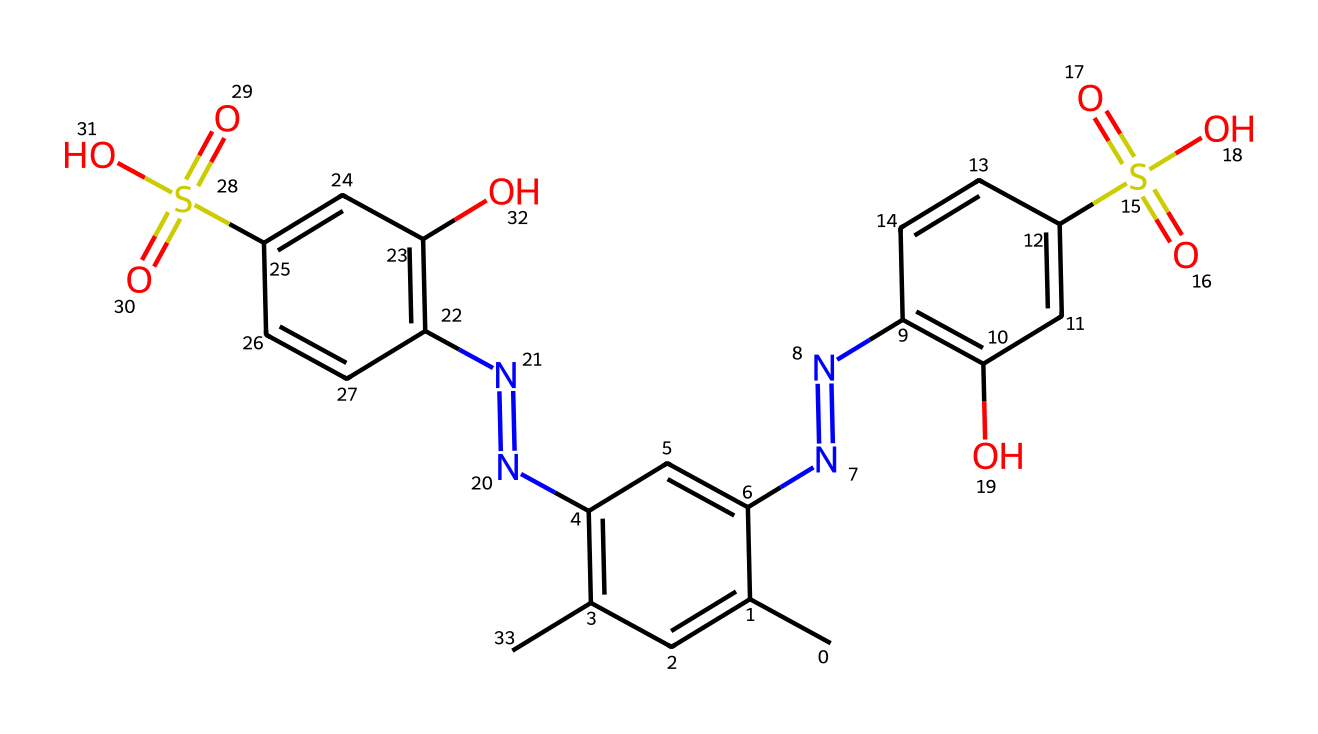what is the total number of carbon atoms in the molecule? To find the total number of carbon atoms, count the "C" indicated in the SMILES representation. By analyzing the structure, there are 16 carbon atoms in total.
Answer: 16 how many nitrogen atoms are present in the chemical structure? Count the number of "N" in the SMILES representation. There are 4 nitrogen atoms visible in this chemical structure, indicating its multiple amine groups.
Answer: 4 what is the primary functional group in this compound? In the chemical structure, we can see the presence of sulfonic acid groups (–SO3H) attached to aromatic rings. This indicates that the primary functional groups are sulfonic acids due to the presence of sulfur and oxygen.
Answer: sulfonic acid what impact does the presence of sulfonic acid groups have on solubility? The presence of sulfonic acid groups increases the molecule's polarity substantially, making it more soluble in polar solvents such as water. This solubility is useful for color-shifting dyes in vision tests.
Answer: increases solubility how many distinct aromatic rings are present in the chemical? By examining the structure, we can identify two distinct aromatic rings within the molecule as indicated by the alternating double bonds, showcasing the planar nature of these components.
Answer: 2 what role do the color-shifting dyes play in vision tests? Color-shifting dyes are utilized in vision tests as they can indicate differences in visual perception by changing color in response to various stimuli, helping to assess color vision deficiencies effectively.
Answer: indicate color vision differences 